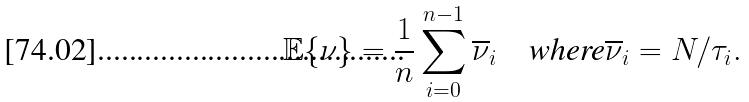<formula> <loc_0><loc_0><loc_500><loc_500>\mathbb { E } \{ \nu \} = \frac { 1 } { n } \sum _ { i = 0 } ^ { n - 1 } \overline { \nu } _ { i } \quad \text {where$\overline{\nu}_{i}=N/\tau_{i}$} .</formula> 